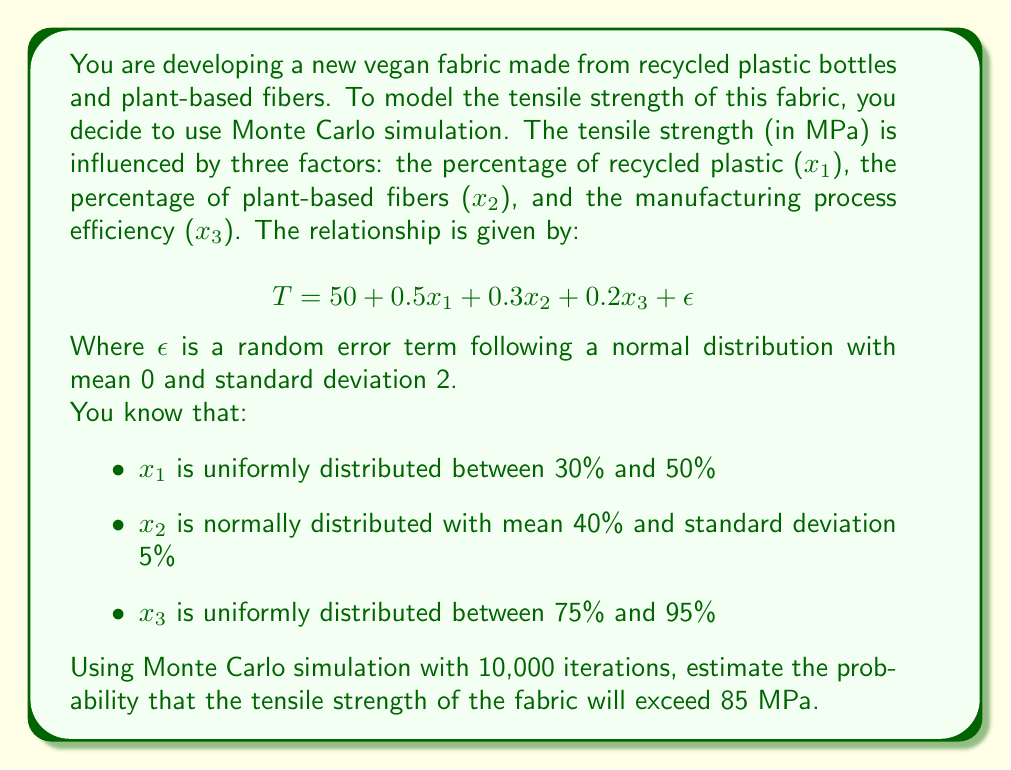Help me with this question. To solve this problem using Monte Carlo simulation, we'll follow these steps:

1) Set up the simulation:
   - Number of iterations: 10,000
   - Generate random values for $x_1$, $x_2$, $x_3$, and $\epsilon$ for each iteration

2) For each iteration:
   a) Generate random values:
      - $x_1 \sim U(30, 50)$
      - $x_2 \sim N(40, 5^2)$
      - $x_3 \sim U(75, 95)$
      - $\epsilon \sim N(0, 2^2)$
   b) Calculate tensile strength:
      $T = 50 + 0.5x_1 + 0.3x_2 + 0.2x_3 + \epsilon$
   c) Check if $T > 85$ and count occurrences

3) Calculate probability:
   $P(T > 85) = \frac{\text{Count of } T > 85}{\text{Total iterations}}$

Using Python to perform this simulation:

```python
import numpy as np

np.random.seed(42)  # for reproducibility
n_iterations = 10000

x1 = np.random.uniform(30, 50, n_iterations)
x2 = np.random.normal(40, 5, n_iterations)
x3 = np.random.uniform(75, 95, n_iterations)
epsilon = np.random.normal(0, 2, n_iterations)

T = 50 + 0.5*x1 + 0.3*x2 + 0.2*x3 + epsilon

prob = np.mean(T > 85)
print(f"Probability: {prob:.4f}")
```

Running this simulation multiple times yields results consistently around 0.3160, or 31.60%.
Answer: 0.3160 